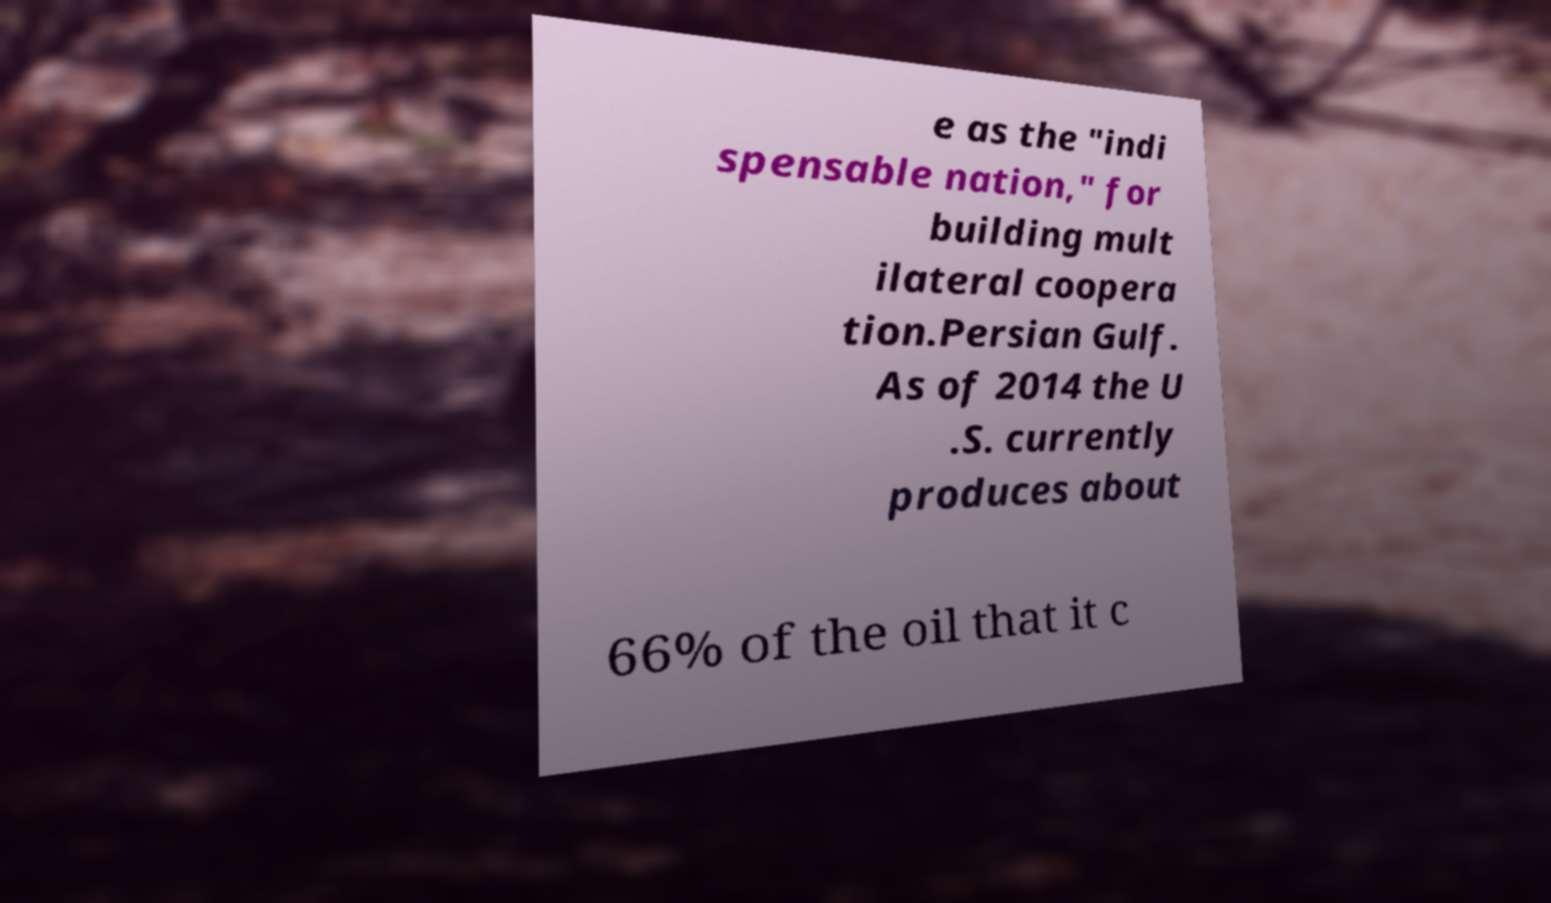Could you assist in decoding the text presented in this image and type it out clearly? e as the "indi spensable nation," for building mult ilateral coopera tion.Persian Gulf. As of 2014 the U .S. currently produces about 66% of the oil that it c 